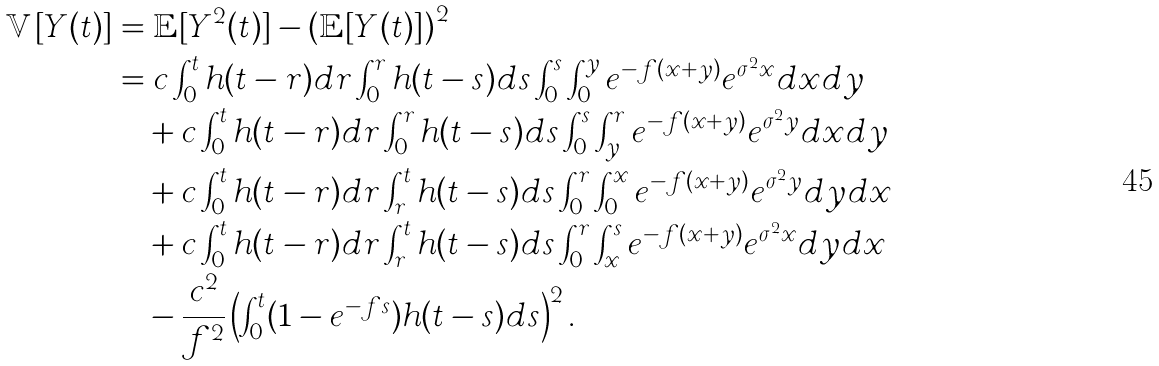Convert formula to latex. <formula><loc_0><loc_0><loc_500><loc_500>\mathbb { V } [ Y ( t ) ] & = \mathbb { E } [ Y ^ { 2 } ( t ) ] - \left ( \mathbb { E } [ Y ( t ) ] \right ) ^ { 2 } \\ & = c \int _ { 0 } ^ { t } h ( t - r ) d r \int _ { 0 } ^ { r } h ( t - s ) d s \int _ { 0 } ^ { s } \int _ { 0 } ^ { y } e ^ { - f ( x + y ) } e ^ { \sigma ^ { 2 } x } d x d y \\ & \quad + c \int _ { 0 } ^ { t } h ( t - r ) d r \int _ { 0 } ^ { r } h ( t - s ) d s \int _ { 0 } ^ { s } \int _ { y } ^ { r } e ^ { - f ( x + y ) } e ^ { \sigma ^ { 2 } y } d x d y \\ & \quad + c \int _ { 0 } ^ { t } h ( t - r ) d r \int _ { r } ^ { t } h ( t - s ) d s \int _ { 0 } ^ { r } \int _ { 0 } ^ { x } e ^ { - f ( x + y ) } e ^ { \sigma ^ { 2 } y } d y d x \\ & \quad + c \int _ { 0 } ^ { t } h ( t - r ) d r \int _ { r } ^ { t } h ( t - s ) d s \int _ { 0 } ^ { r } \int _ { x } ^ { s } e ^ { - f ( x + y ) } e ^ { \sigma ^ { 2 } x } d y d x \\ & \quad - \frac { c ^ { 2 } } { f ^ { 2 } } \left ( \int _ { 0 } ^ { t } ( 1 - e ^ { - f s } ) h ( t - s ) d s \right ) ^ { 2 } .</formula> 